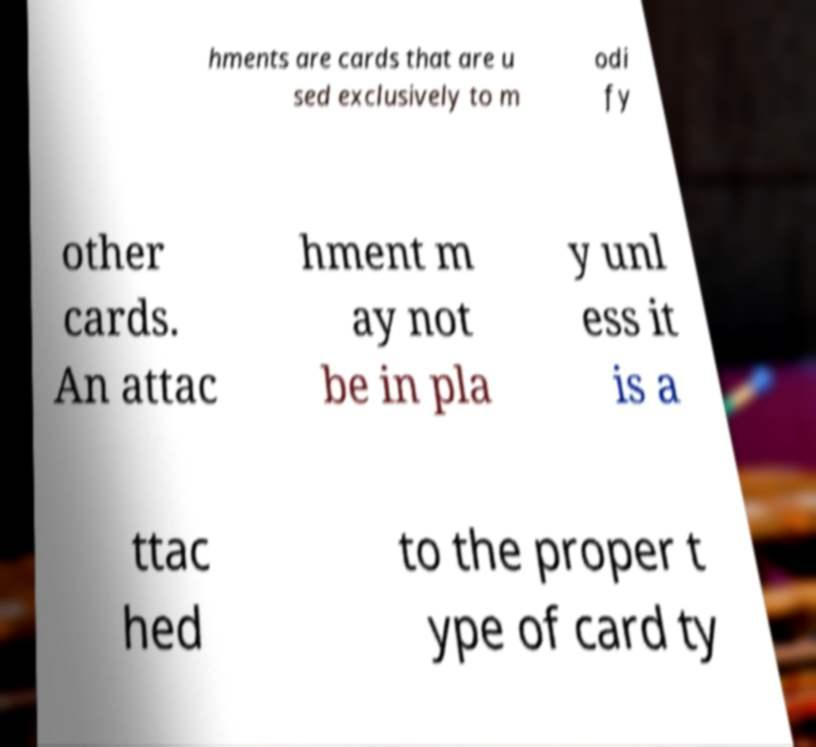Could you extract and type out the text from this image? hments are cards that are u sed exclusively to m odi fy other cards. An attac hment m ay not be in pla y unl ess it is a ttac hed to the proper t ype of card ty 